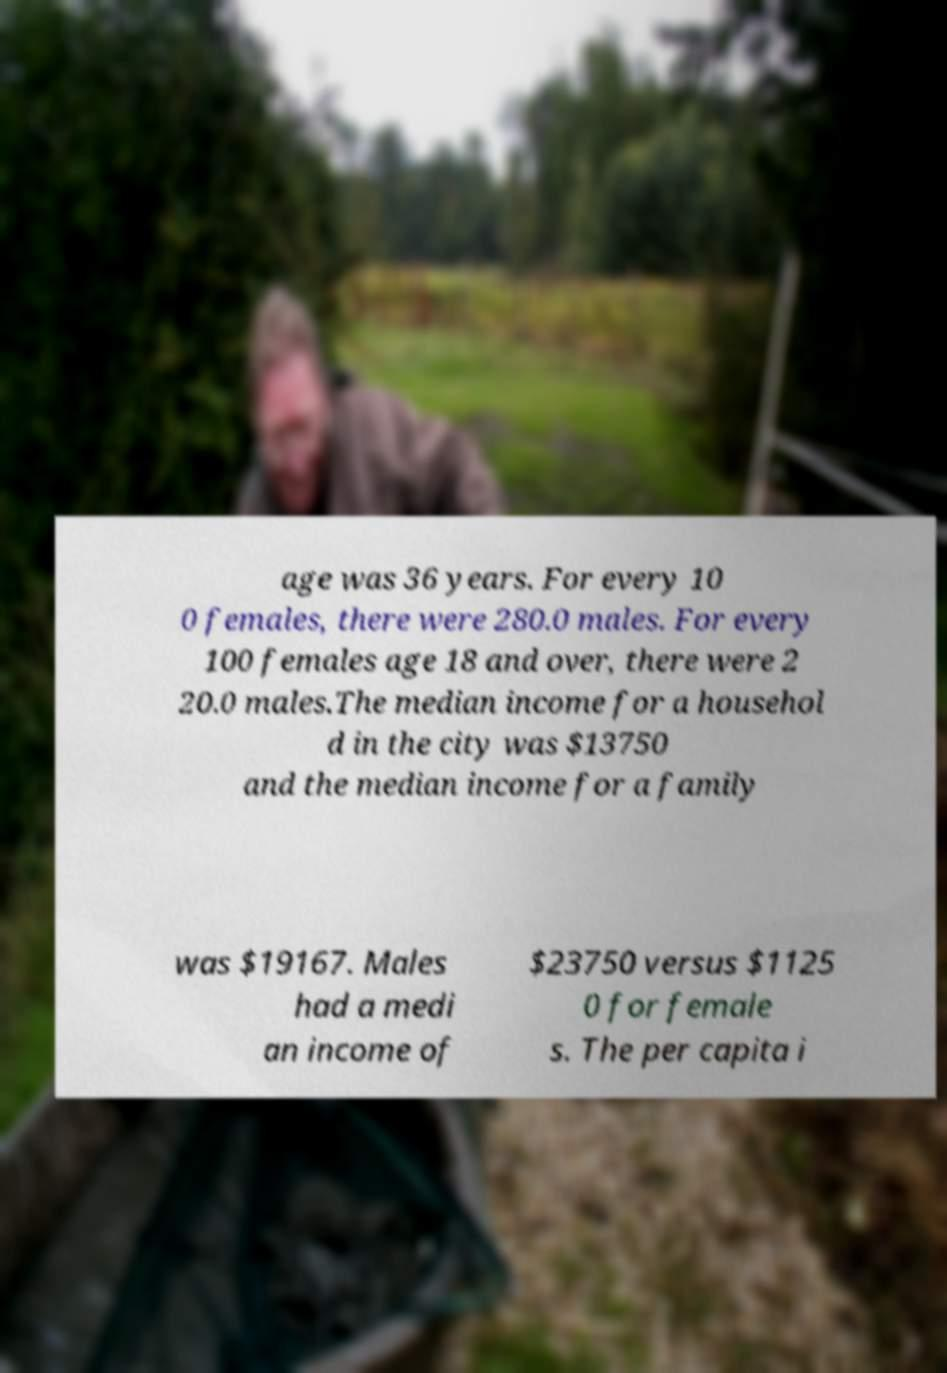Can you accurately transcribe the text from the provided image for me? age was 36 years. For every 10 0 females, there were 280.0 males. For every 100 females age 18 and over, there were 2 20.0 males.The median income for a househol d in the city was $13750 and the median income for a family was $19167. Males had a medi an income of $23750 versus $1125 0 for female s. The per capita i 